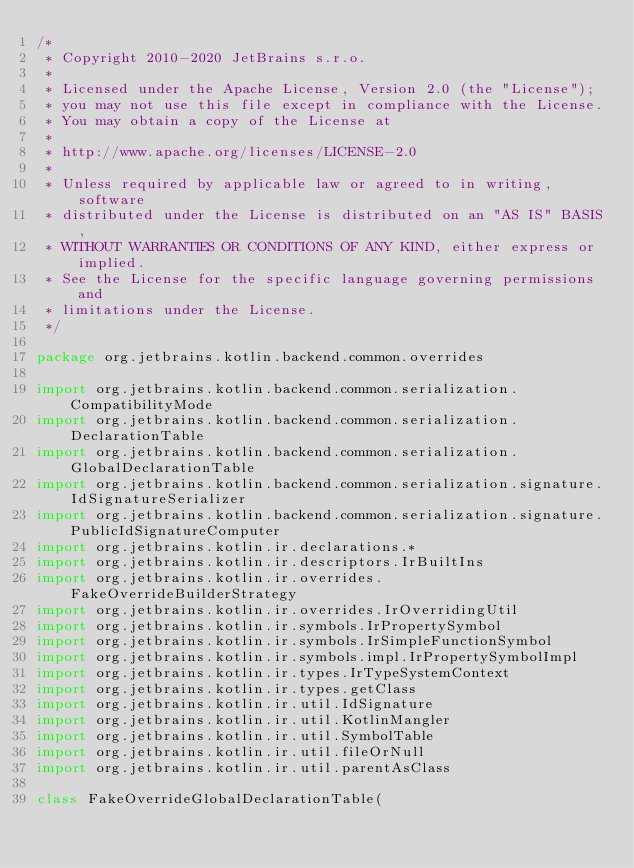Convert code to text. <code><loc_0><loc_0><loc_500><loc_500><_Kotlin_>/*
 * Copyright 2010-2020 JetBrains s.r.o.
 *
 * Licensed under the Apache License, Version 2.0 (the "License");
 * you may not use this file except in compliance with the License.
 * You may obtain a copy of the License at
 *
 * http://www.apache.org/licenses/LICENSE-2.0
 *
 * Unless required by applicable law or agreed to in writing, software
 * distributed under the License is distributed on an "AS IS" BASIS,
 * WITHOUT WARRANTIES OR CONDITIONS OF ANY KIND, either express or implied.
 * See the License for the specific language governing permissions and
 * limitations under the License.
 */

package org.jetbrains.kotlin.backend.common.overrides

import org.jetbrains.kotlin.backend.common.serialization.CompatibilityMode
import org.jetbrains.kotlin.backend.common.serialization.DeclarationTable
import org.jetbrains.kotlin.backend.common.serialization.GlobalDeclarationTable
import org.jetbrains.kotlin.backend.common.serialization.signature.IdSignatureSerializer
import org.jetbrains.kotlin.backend.common.serialization.signature.PublicIdSignatureComputer
import org.jetbrains.kotlin.ir.declarations.*
import org.jetbrains.kotlin.ir.descriptors.IrBuiltIns
import org.jetbrains.kotlin.ir.overrides.FakeOverrideBuilderStrategy
import org.jetbrains.kotlin.ir.overrides.IrOverridingUtil
import org.jetbrains.kotlin.ir.symbols.IrPropertySymbol
import org.jetbrains.kotlin.ir.symbols.IrSimpleFunctionSymbol
import org.jetbrains.kotlin.ir.symbols.impl.IrPropertySymbolImpl
import org.jetbrains.kotlin.ir.types.IrTypeSystemContext
import org.jetbrains.kotlin.ir.types.getClass
import org.jetbrains.kotlin.ir.util.IdSignature
import org.jetbrains.kotlin.ir.util.KotlinMangler
import org.jetbrains.kotlin.ir.util.SymbolTable
import org.jetbrains.kotlin.ir.util.fileOrNull
import org.jetbrains.kotlin.ir.util.parentAsClass

class FakeOverrideGlobalDeclarationTable(</code> 